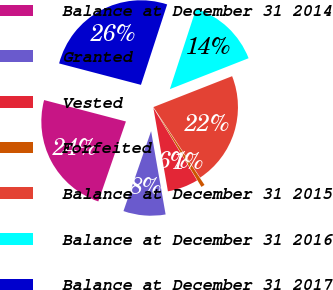Convert chart to OTSL. <chart><loc_0><loc_0><loc_500><loc_500><pie_chart><fcel>Balance at December 31 2014<fcel>Granted<fcel>Vested<fcel>Forfeited<fcel>Balance at December 31 2015<fcel>Balance at December 31 2016<fcel>Balance at December 31 2017<nl><fcel>23.78%<fcel>8.04%<fcel>5.89%<fcel>0.69%<fcel>21.63%<fcel>14.03%<fcel>25.94%<nl></chart> 